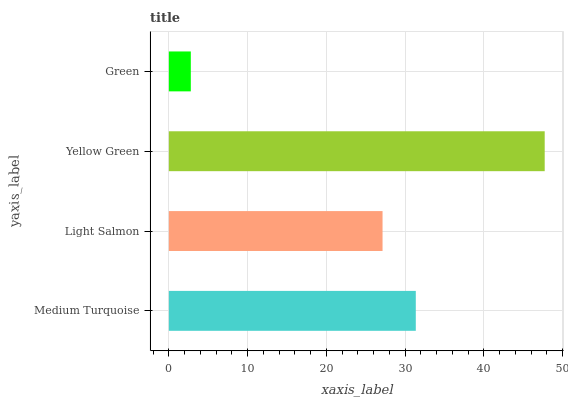Is Green the minimum?
Answer yes or no. Yes. Is Yellow Green the maximum?
Answer yes or no. Yes. Is Light Salmon the minimum?
Answer yes or no. No. Is Light Salmon the maximum?
Answer yes or no. No. Is Medium Turquoise greater than Light Salmon?
Answer yes or no. Yes. Is Light Salmon less than Medium Turquoise?
Answer yes or no. Yes. Is Light Salmon greater than Medium Turquoise?
Answer yes or no. No. Is Medium Turquoise less than Light Salmon?
Answer yes or no. No. Is Medium Turquoise the high median?
Answer yes or no. Yes. Is Light Salmon the low median?
Answer yes or no. Yes. Is Light Salmon the high median?
Answer yes or no. No. Is Medium Turquoise the low median?
Answer yes or no. No. 